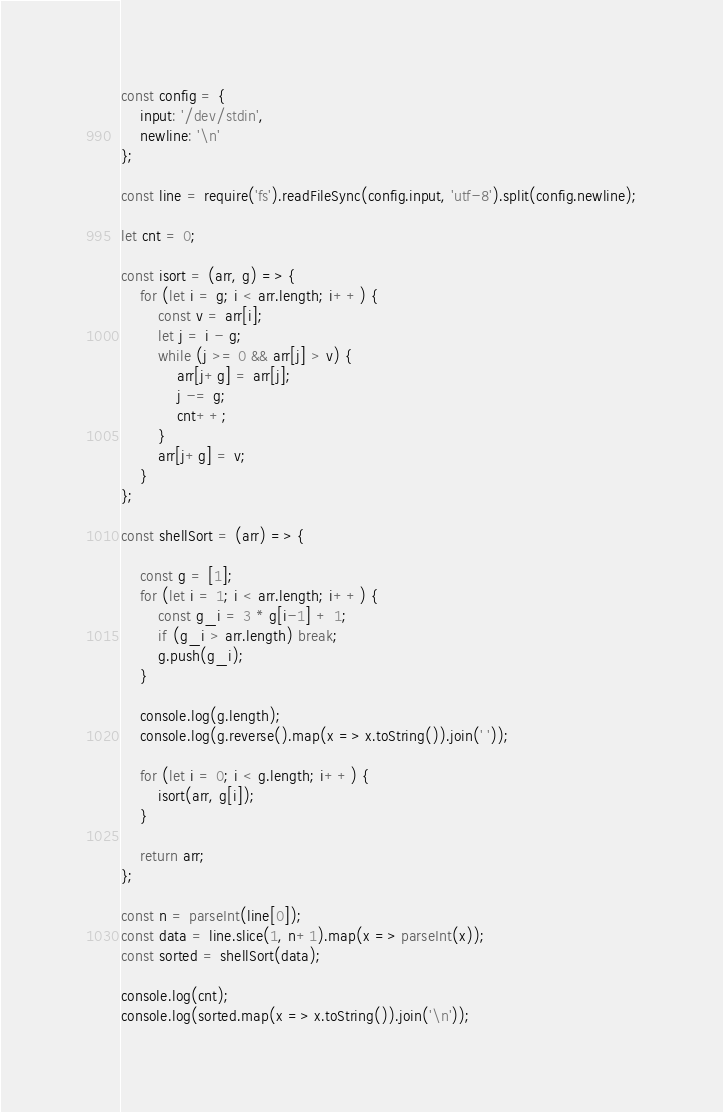<code> <loc_0><loc_0><loc_500><loc_500><_JavaScript_>const config = {
    input: '/dev/stdin',
    newline: '\n'
};

const line = require('fs').readFileSync(config.input, 'utf-8').split(config.newline);

let cnt = 0;

const isort = (arr, g) => {
    for (let i = g; i < arr.length; i++) {
        const v = arr[i];
        let j = i - g;
        while (j >= 0 && arr[j] > v) {
            arr[j+g] = arr[j];
            j -= g;
            cnt++;
        }
        arr[j+g] = v;
    }
};

const shellSort = (arr) => {

    const g = [1];
    for (let i = 1; i < arr.length; i++) {
        const g_i = 3 * g[i-1] + 1;
        if (g_i > arr.length) break;
        g.push(g_i);
    }

    console.log(g.length);
    console.log(g.reverse().map(x => x.toString()).join(' '));

    for (let i = 0; i < g.length; i++) {
        isort(arr, g[i]);
    }

    return arr;
};

const n = parseInt(line[0]);
const data = line.slice(1, n+1).map(x => parseInt(x));
const sorted = shellSort(data);

console.log(cnt);
console.log(sorted.map(x => x.toString()).join('\n'));

</code> 